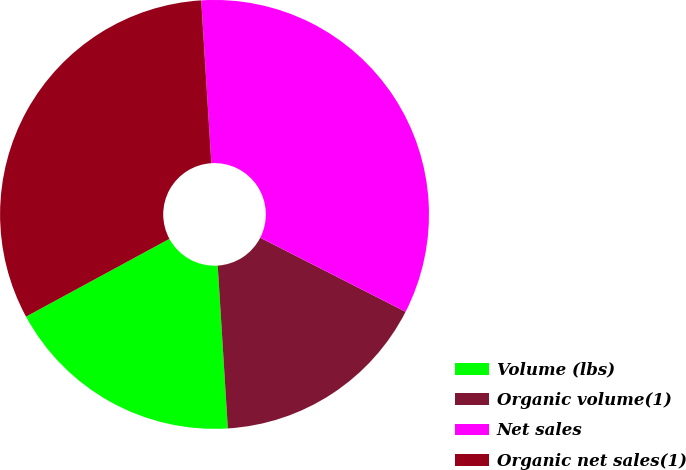Convert chart to OTSL. <chart><loc_0><loc_0><loc_500><loc_500><pie_chart><fcel>Volume (lbs)<fcel>Organic volume(1)<fcel>Net sales<fcel>Organic net sales(1)<nl><fcel>18.08%<fcel>16.51%<fcel>33.49%<fcel>31.92%<nl></chart> 